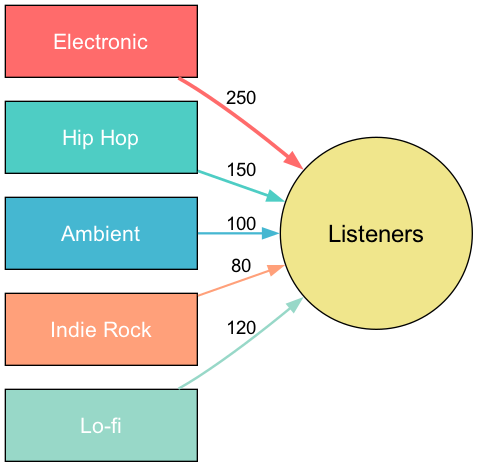What is the number of genre nodes in the diagram? The diagram contains five genre nodes: Electronic, Hip Hop, Ambient, Indie Rock, and Lo-fi. Counting these nodes gives a total of five genre nodes.
Answer: 5 Which genre has the highest listener engagement? By examining the links, we see that Electronic has the highest value of 250, indicating the most listener engagement compared to the other genres.
Answer: Electronic What is the value of listeners for Ambient? The link connecting Ambient to Listeners shows a value of 100. Therefore, the listener engagement for Ambient is 100.
Answer: 100 What is the total number of listeners across all genres? To find the total, we add the values of all links: 250 (Electronic) + 150 (Hip Hop) + 100 (Ambient) + 80 (Indie Rock) + 120 (Lo-fi) = 700. The total number of listeners is 700.
Answer: 700 Which genre has the lowest listener engagement? By looking at the values for each genre, Indie Rock has the lowest link value of 80 when compared to each of the other genres.
Answer: Indie Rock What percentage of listeners are engaged with Hip Hop compared to the total? The value for Hip Hop is 150. To find the percentage, we calculate (150/700) * 100 = 21.43%. Therefore, about 21.43% of listeners engage with Hip Hop.
Answer: 21.43% How many different genres show listener engagement below 150? By examining the values, we see that Ambient (100), Indie Rock (80), and Lo-fi (120) have values below 150. That gives us three genres with engagement below that threshold.
Answer: 3 Which genre has the second highest listener engagement? The values ranked from highest to lowest reveal that after Electronic (250), Hip Hop (150) holds the second position in listener engagement.
Answer: Hip Hop What is the ratio of Lo-fi listeners to Ambient listeners? The values for Lo-fi and Ambient are 120 and 100, respectively. The ratio is calculated as 120:100, which simplifies to 6:5. Therefore, the ratio of Lo-fi listeners to Ambient listeners is 6:5.
Answer: 6:5 